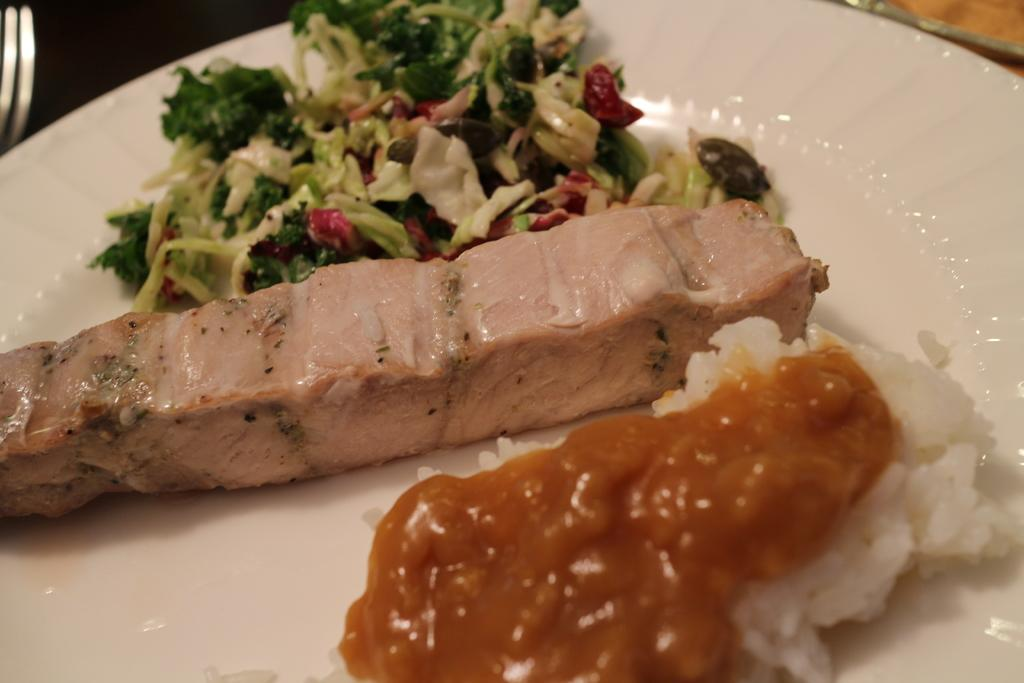What is on the plate that is visible in the image? The plate contains salad. What type of food is on the plate? The plate contains food, specifically salad. Where is the plate located in the image? The plate is placed on a table. Is there a crown on the plate in the image? No, there is no crown present on the plate in the image. 